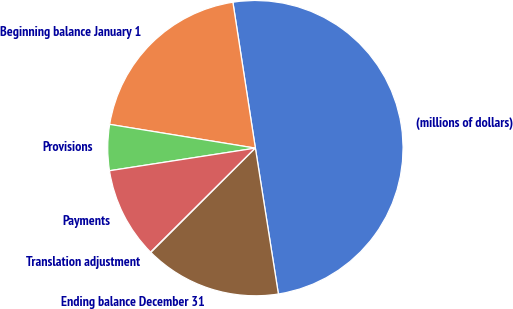Convert chart. <chart><loc_0><loc_0><loc_500><loc_500><pie_chart><fcel>(millions of dollars)<fcel>Beginning balance January 1<fcel>Provisions<fcel>Payments<fcel>Translation adjustment<fcel>Ending balance December 31<nl><fcel>49.94%<fcel>19.99%<fcel>5.02%<fcel>10.01%<fcel>0.03%<fcel>15.0%<nl></chart> 